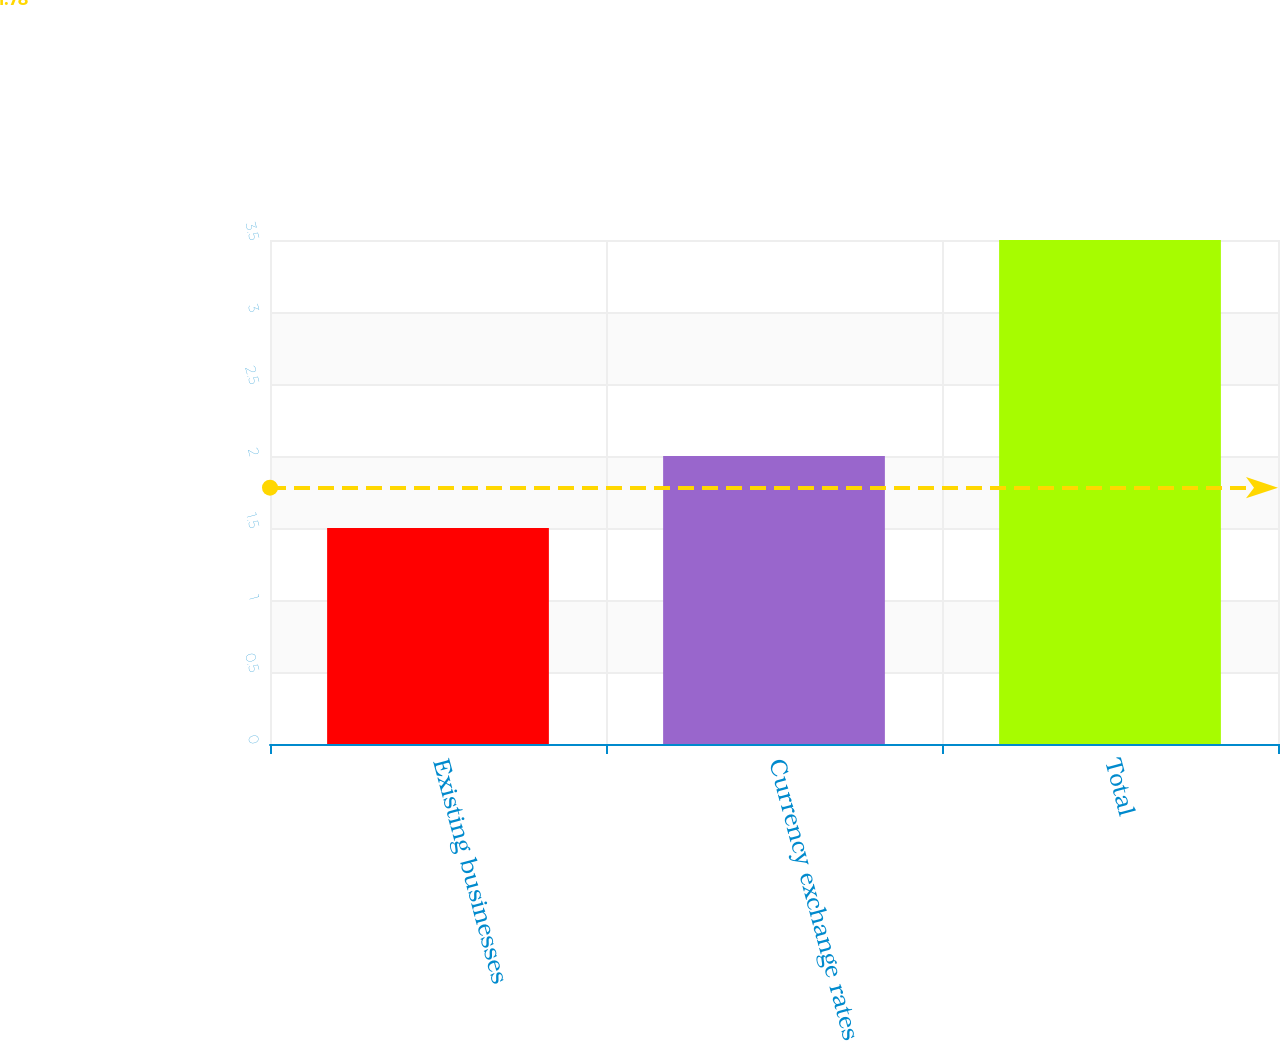<chart> <loc_0><loc_0><loc_500><loc_500><bar_chart><fcel>Existing businesses<fcel>Currency exchange rates<fcel>Total<nl><fcel>1.5<fcel>2<fcel>3.5<nl></chart> 